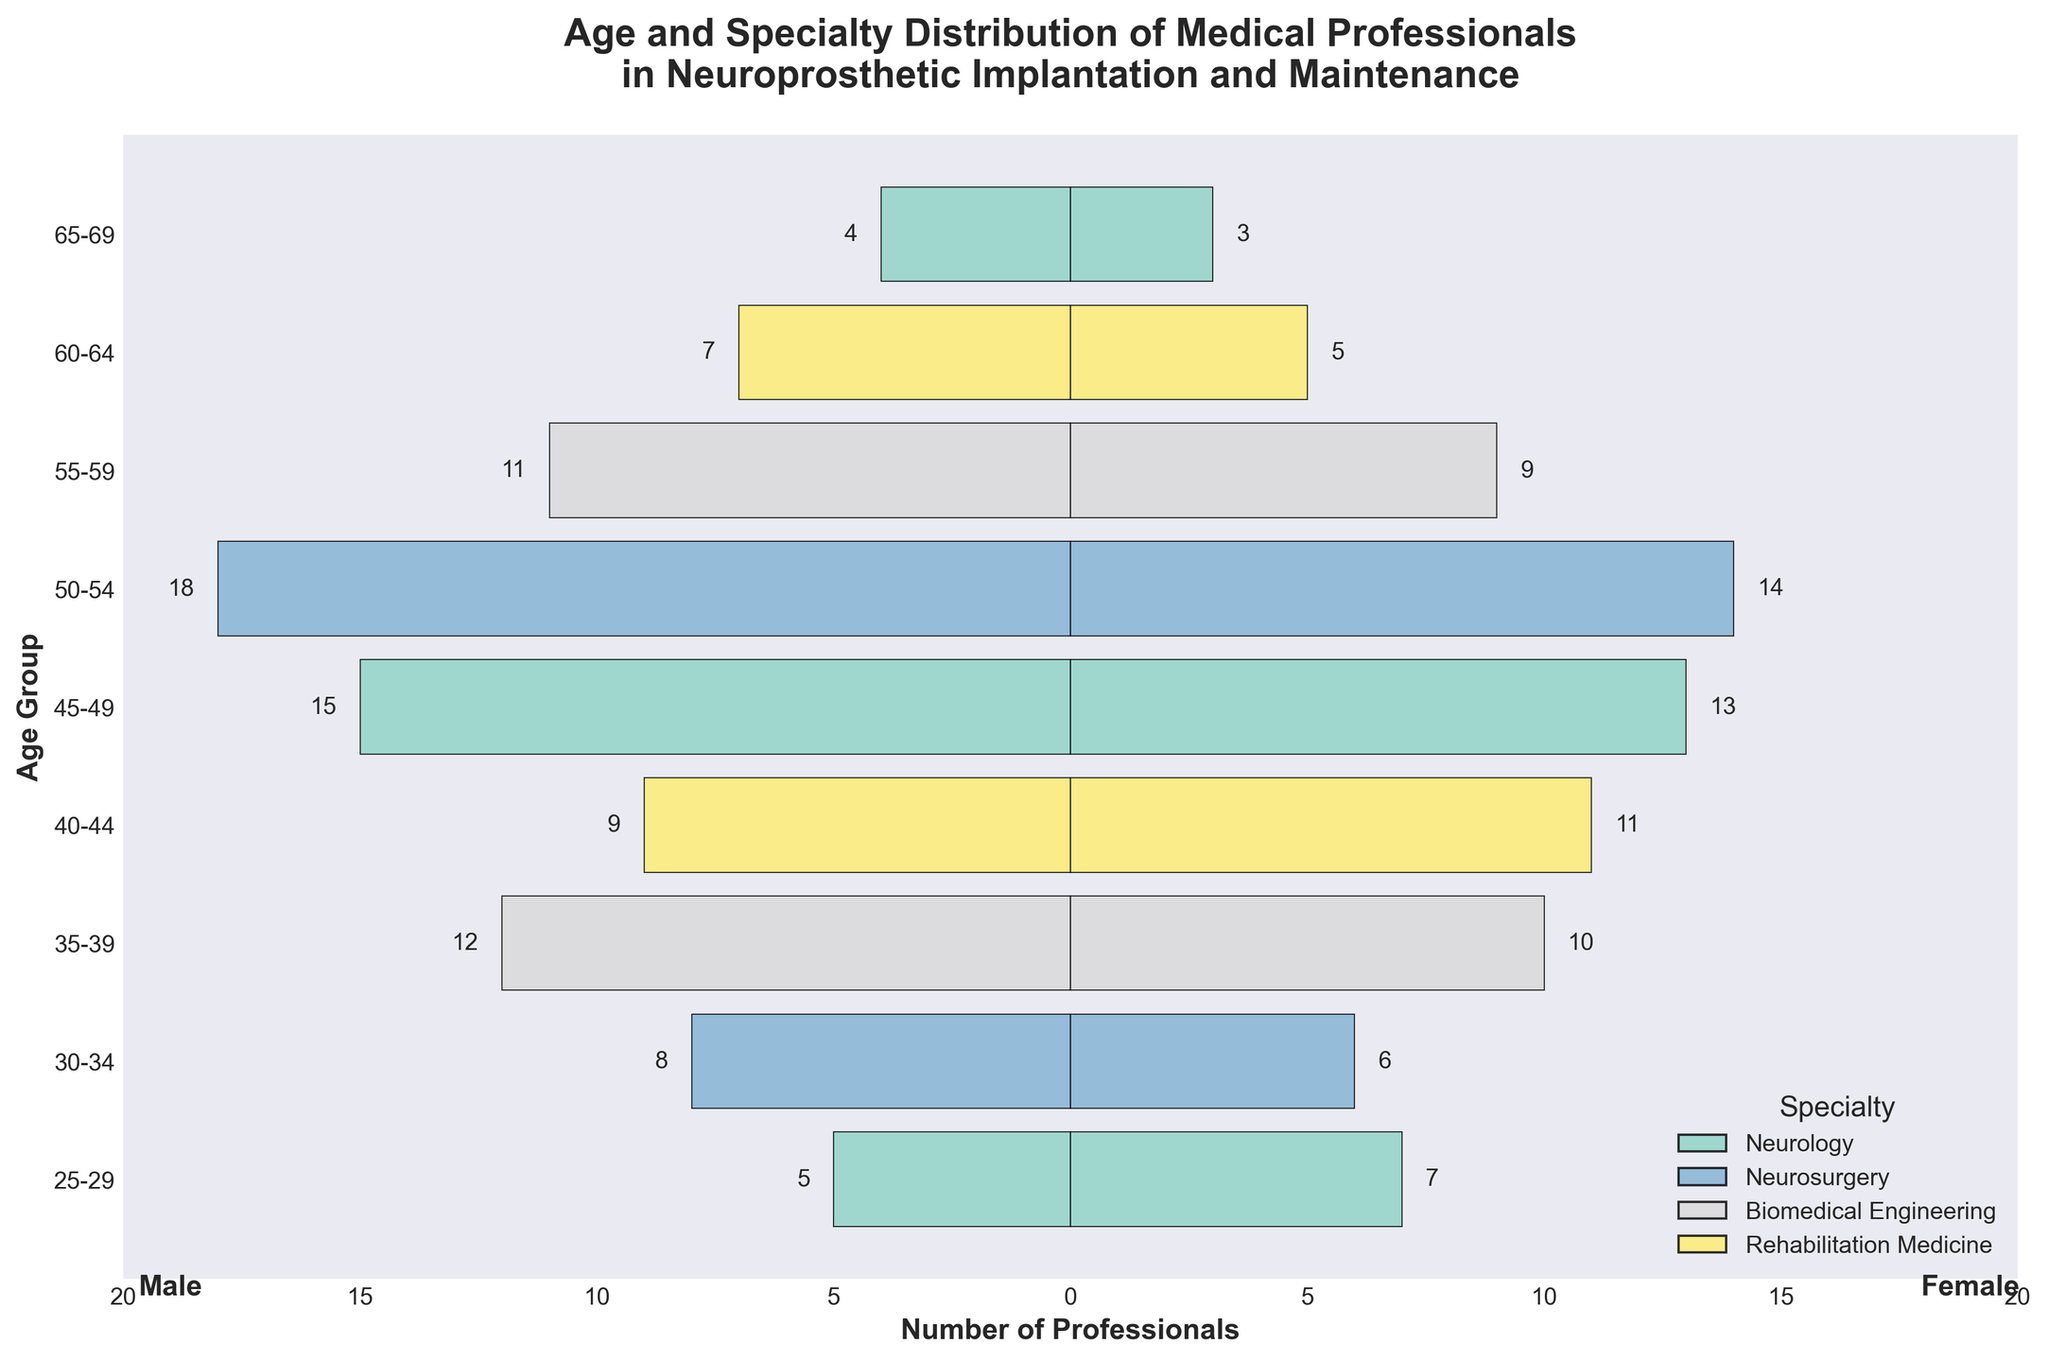What is the title of the plot? The title is shown at the top of the plot and describes the main topic of the figure. The title reads: "Age and Specialty Distribution of Medical Professionals in Neuroprosthetic Implantation and Maintenance".
Answer: "Age and Specialty Distribution of Medical Professionals in Neuroprosthetic Implantation and Maintenance" Which age group has the highest number of male professionals in Neurosurgery? By looking at the bars for male professionals (which are negative values) and identifying those that belong to Neurosurgery in different age groups, the age group 50-54 has the highest number with 18 male professionals.
Answer: 50-54 What is the total number of female professionals in Rehabilitation Medicine across all age groups? Sum the female professionals in Rehabilitation Medicine for the 40-44 and 60-64 age groups: 11 (for 40-44) + 5 (for 60-64).
Answer: 16 How many more male professionals are there than female professionals in the 35-39 age group for Biomedical Engineering? For the 35-39 age group in Biomedical Engineering, there are 12 male professionals and 10 female professionals. The difference is: 12 - 10.
Answer: 2 Which specialty has the most balanced gender distribution in the 45-49 age group? By comparing the number of male and female professionals in each specialty within the 45-49 age group, Neurology has 15 males and 13 females, making it the most balanced in this age group.
Answer: Neurology In which age group is the gender distribution most skewed towards females? Look at the bars for female professionals (positive values) and compare them to male professionals (negative values) to determine which age group shows the greatest difference skewed towards females. The 25-29 age group in Neurology has 5 males and 7 females which is the highest relative difference favoring females.
Answer: 25-29 What is the combined total of male and female Neurosurgery professionals in the 30-34 age group? Add together the number of male (8) and female (6) professionals in Neurosurgery within the 30-34 age group: 8 + 6.
Answer: 14 Which age group has the smallest overall number of professionals? By analyzing both sides of the pyramid and summing up the male and female professionals for each age group, the 65-69 age group has the smallest total with 4 males and 3 females.
Answer: 65-69 Which specialty shows the highest increase in male professionals from the 45-49 age group to the 50-54 age group? Compare the number of male professionals in the 45-49 and 50-54 age groups for each specialty. Neurosurgery increases from 15 to 18 males, showing the highest increase.
Answer: Neurosurgery 